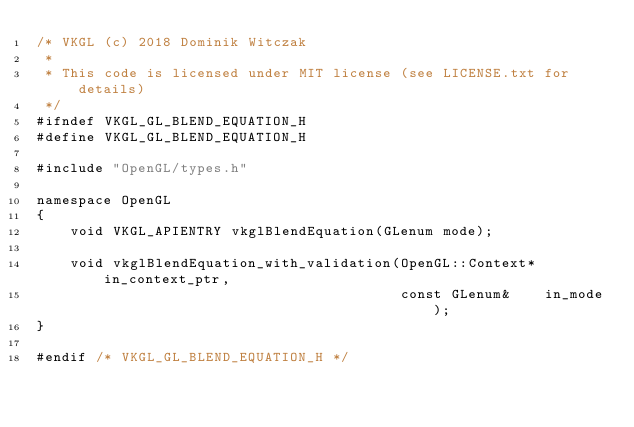<code> <loc_0><loc_0><loc_500><loc_500><_C_>/* VKGL (c) 2018 Dominik Witczak
 *
 * This code is licensed under MIT license (see LICENSE.txt for details)
 */
#ifndef VKGL_GL_BLEND_EQUATION_H
#define VKGL_GL_BLEND_EQUATION_H

#include "OpenGL/types.h"

namespace OpenGL
{
    void VKGL_APIENTRY vkglBlendEquation(GLenum mode);

    void vkglBlendEquation_with_validation(OpenGL::Context* in_context_ptr,
                                           const GLenum&    in_mode);
}

#endif /* VKGL_GL_BLEND_EQUATION_H */</code> 